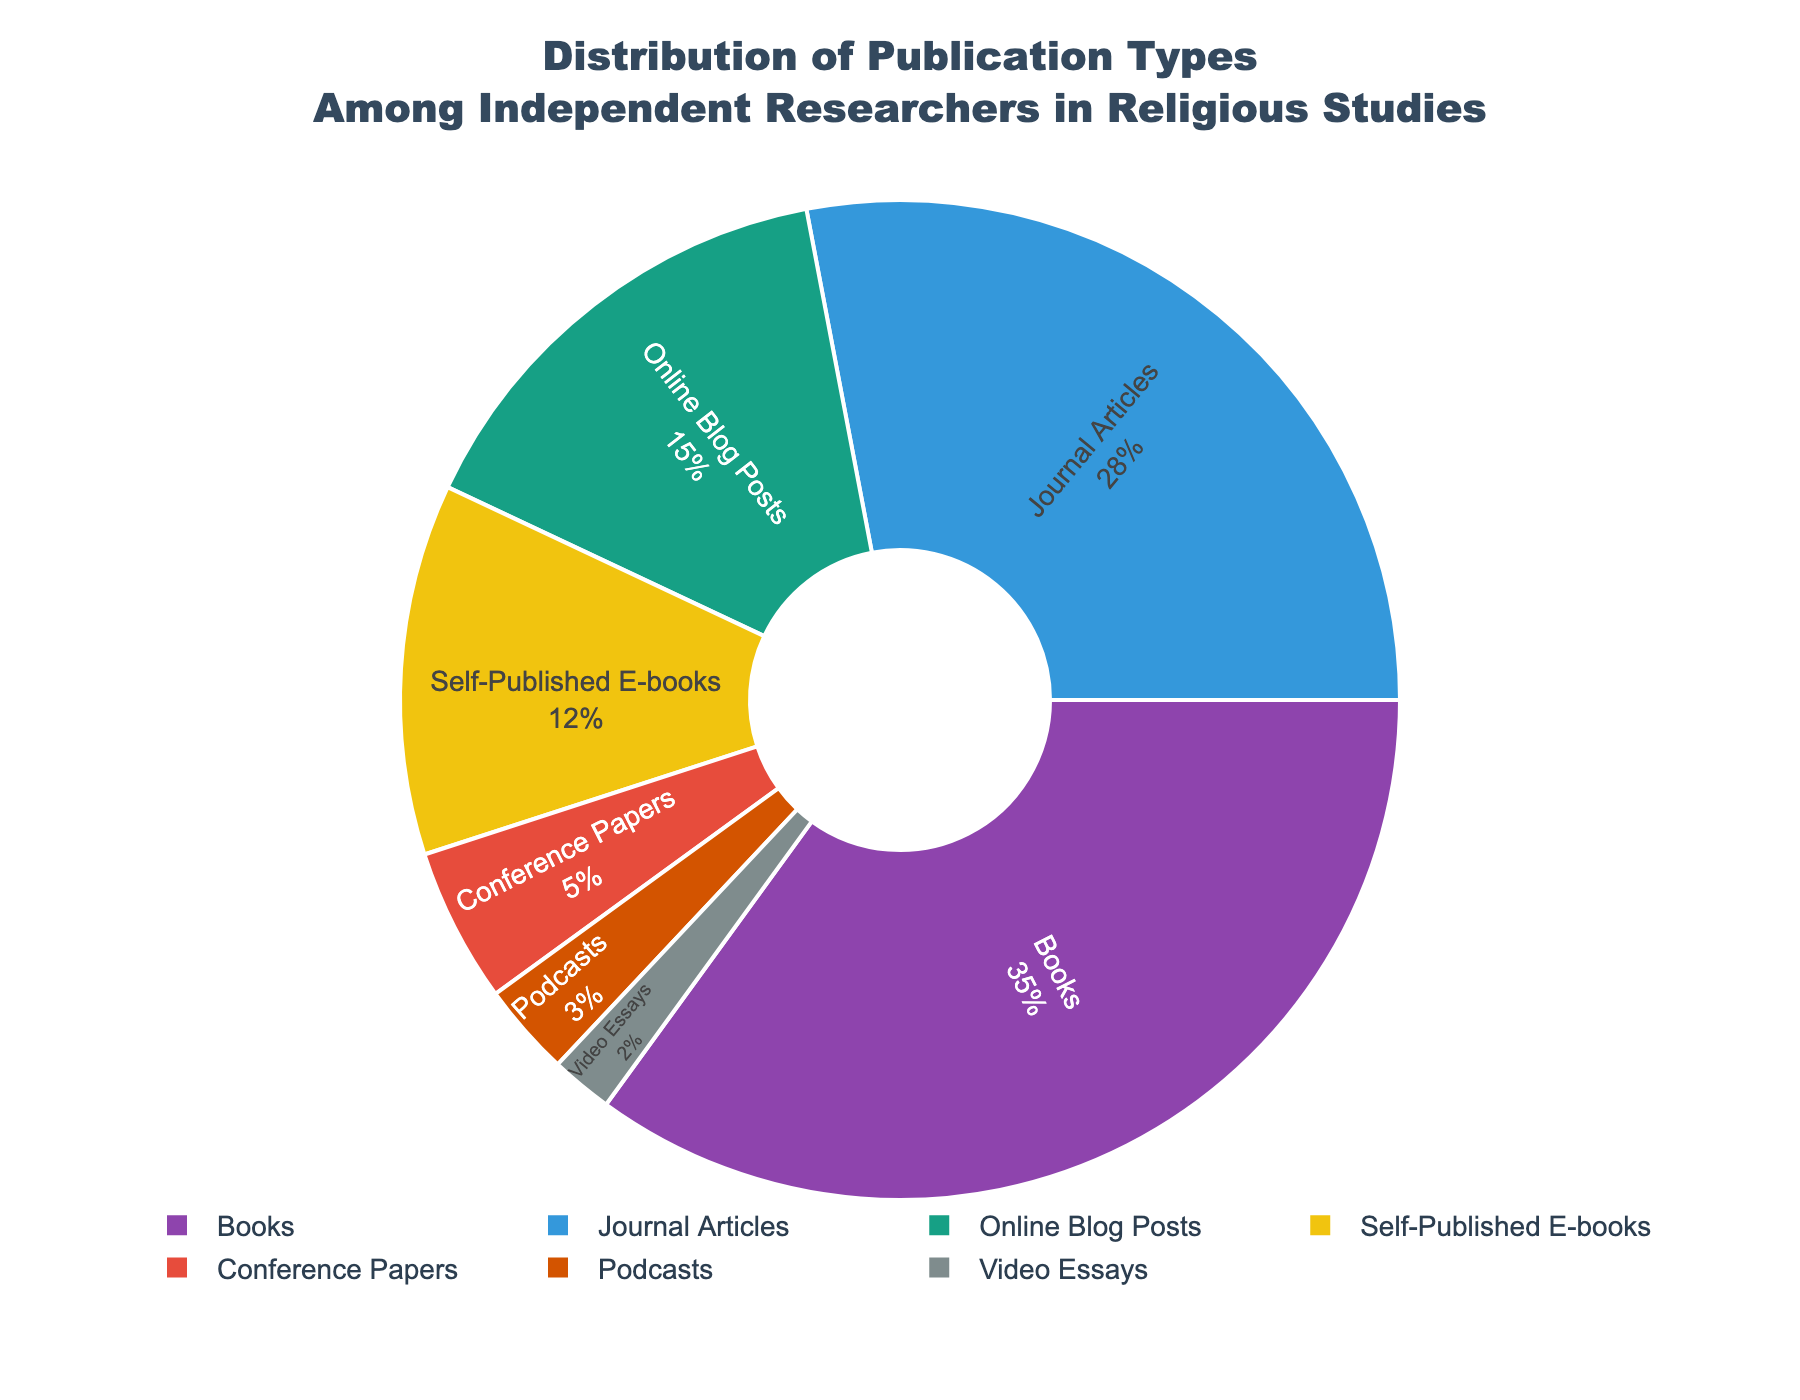What's the most common type of publication among independent researchers in religious studies? According to the pie chart, the slice representing "Books" is the largest, indicating that it is the most common type of publication.
Answer: Books Which publication type has a smaller proportion than self-published e-books but larger than podcasts? Self-published e-books constitute 12%. Conference Papers constitute 5%, which is smaller than 12%, and Online Blog Posts constitute 15%, which is larger than 12%.
Answer: Conference Papers What is the combined percentage of publications that are not books, journal articles, or online blog posts? Books, journal articles, and online blog posts make up 35% + 28% + 15% = 78%. Therefore, the other types make up 100% - 78% = 22%.
Answer: 22% Compare the percentage of journal articles to podcasts. Which one is greater and by how much? Journal articles have a percentage of 28% while podcasts have 3%. The difference is 28% - 3% = 25%.
Answer: Journal Articles by 25% What is the total percentage of all the non-traditional publication types combined (online blog posts, self-published e-books, podcasts, video essays)? Adding the percentages of online blog posts (15%), self-published e-books (12%), podcasts (3%), and video essays (2%) gives 15% + 12% + 3% + 2% = 32%.
Answer: 32% Which publication types have percentages of 5% or less? By looking at the pie chart slices, conference papers have 5%, podcasts have 3%, and video essays have 2%.
Answer: Conference Papers, Podcasts, Video Essays Is the percentage of books more than the combined percentage of self-published e-books, conference papers, and podcasts? Adding self-published e-books (12%), conference papers (5%), and podcasts (3%) gives 12% + 5% + 3% = 20%. Books have 35%. Thus, 35% is more than 20%.
Answer: Yes What fraction of publication types reflect medium-to-long-form content (books and journal articles combined)? The percentage for books is 35% and for journal articles is 28%, adding up to 35% + 28% = 63%, which simplifies to 63/100 or 63/100.
Answer: 63/100 or 63% Which color on the pie chart represents conference papers? The colors cycle in the following order: Books (purple), Journal Articles (blue), Online Blog Posts (green), Self-Published E-books (yellow), Conference Papers (red). Hence, conference papers are represented in red.
Answer: Red What is the difference in percentage between the most and least common publication types? The most common publication type is books at 35%, and the least common is video essays at 2%. The difference is 35% - 2% = 33%.
Answer: 33% 